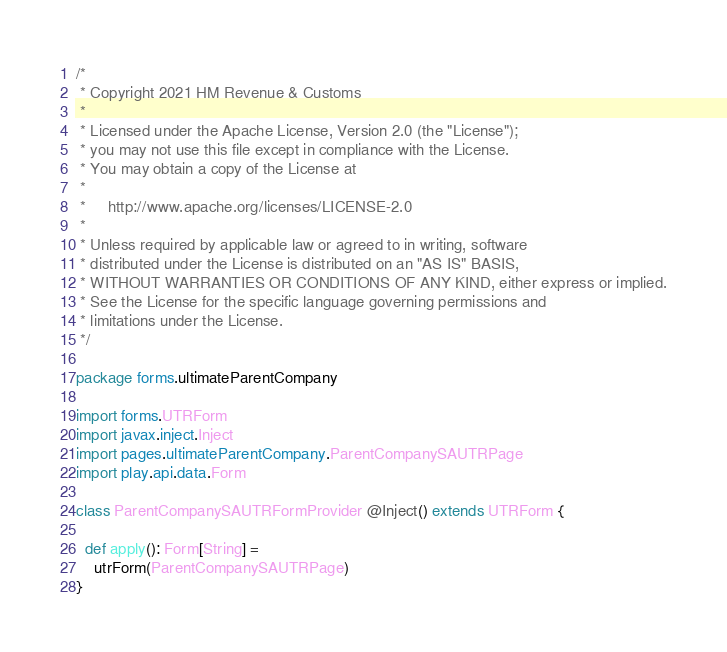<code> <loc_0><loc_0><loc_500><loc_500><_Scala_>/*
 * Copyright 2021 HM Revenue & Customs
 *
 * Licensed under the Apache License, Version 2.0 (the "License");
 * you may not use this file except in compliance with the License.
 * You may obtain a copy of the License at
 *
 *     http://www.apache.org/licenses/LICENSE-2.0
 *
 * Unless required by applicable law or agreed to in writing, software
 * distributed under the License is distributed on an "AS IS" BASIS,
 * WITHOUT WARRANTIES OR CONDITIONS OF ANY KIND, either express or implied.
 * See the License for the specific language governing permissions and
 * limitations under the License.
 */

package forms.ultimateParentCompany

import forms.UTRForm
import javax.inject.Inject
import pages.ultimateParentCompany.ParentCompanySAUTRPage
import play.api.data.Form

class ParentCompanySAUTRFormProvider @Inject() extends UTRForm {

  def apply(): Form[String] =
    utrForm(ParentCompanySAUTRPage)
}
</code> 